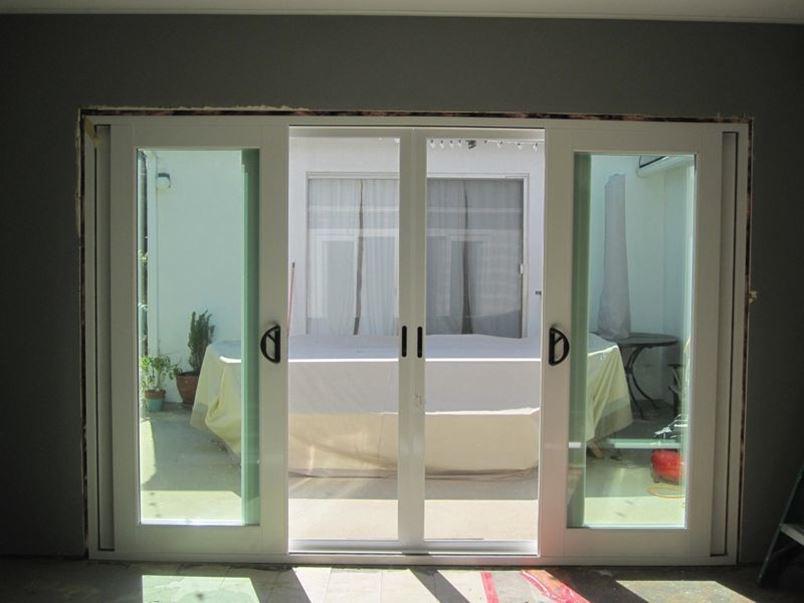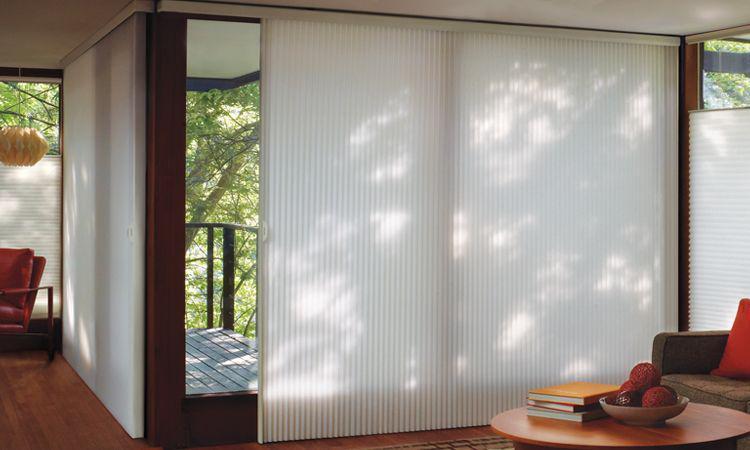The first image is the image on the left, the second image is the image on the right. Evaluate the accuracy of this statement regarding the images: "One of the images has horizontal blinds on the glass doors.". Is it true? Answer yes or no. No. The first image is the image on the left, the second image is the image on the right. For the images displayed, is the sentence "An image shows a rectangle with four white-framed door sections surrounded by grayish wall." factually correct? Answer yes or no. Yes. 